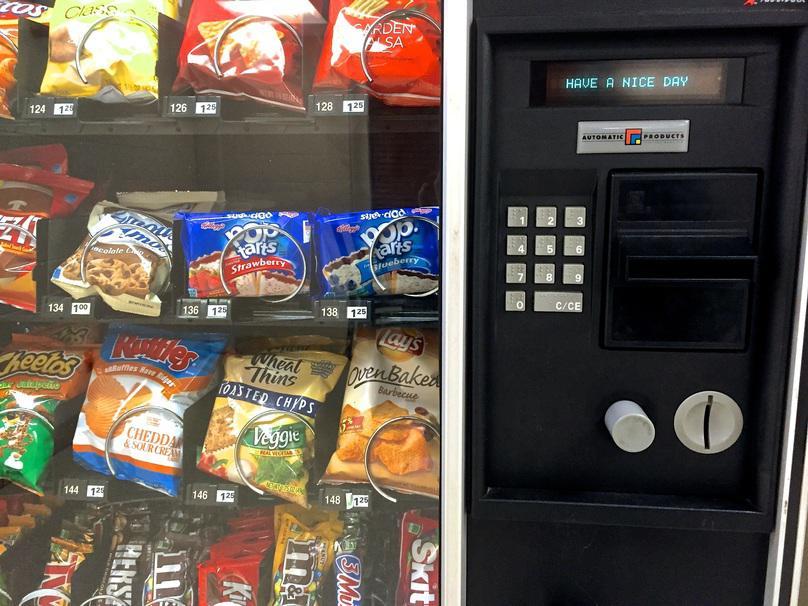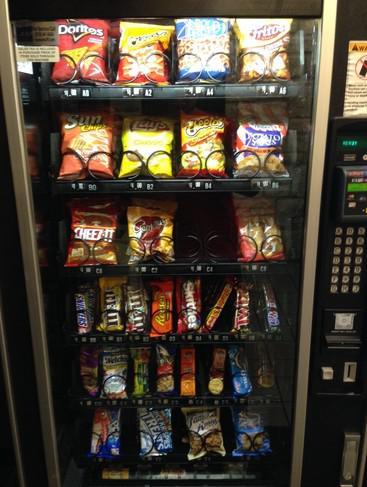The first image is the image on the left, the second image is the image on the right. For the images shown, is this caption "At least one of the images shows snacks that have got stuck in a vending machine." true? Answer yes or no. No. The first image is the image on the left, the second image is the image on the right. Assess this claim about the two images: "There are items falling from their shelves in both images.". Correct or not? Answer yes or no. No. 